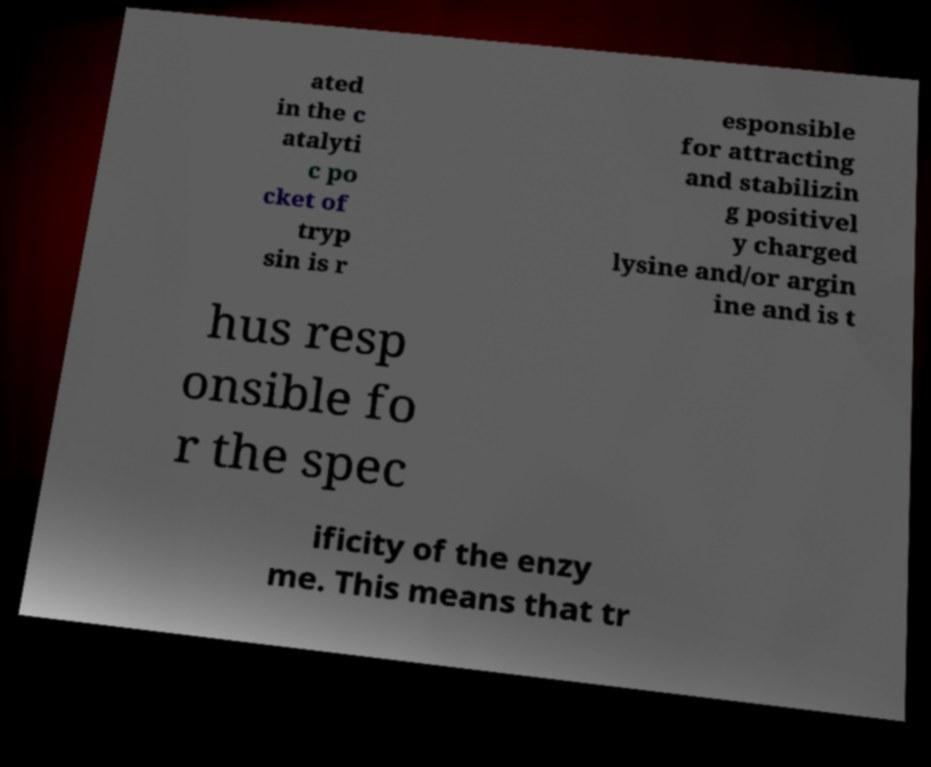There's text embedded in this image that I need extracted. Can you transcribe it verbatim? ated in the c atalyti c po cket of tryp sin is r esponsible for attracting and stabilizin g positivel y charged lysine and/or argin ine and is t hus resp onsible fo r the spec ificity of the enzy me. This means that tr 